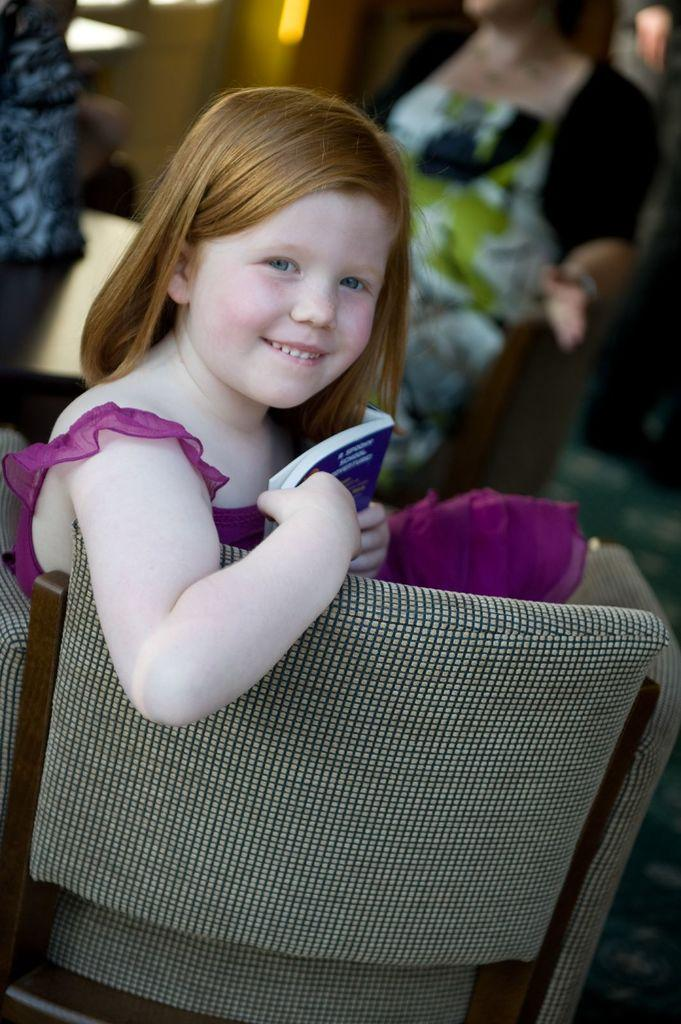Who is the main subject in the image? There is a girl in the image. What is the girl wearing? The girl is wearing a red gown. What expression does the girl have? The girl is smiling. What is the girl holding in the image? The girl is holding a book. What is the girl sitting on in the image? The girl is sitting on a chair. Are there any other people visible in the image? Yes, there are people standing behind the girl. What type of cookware is the girl using in the image? There is no cookware present in the image; the girl is holding a book and wearing a red gown. What is the girl's opinion on the use of a wrench in the image? There is no wrench present in the image, so it is not possible to determine the girl's opinion on its use. 